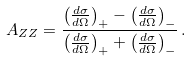Convert formula to latex. <formula><loc_0><loc_0><loc_500><loc_500>A _ { Z Z } = \frac { \left ( \frac { d \sigma } { d \Omega } \right ) _ { + } - \left ( \frac { d \sigma } { d \Omega } \right ) _ { - } } { \left ( \frac { d \sigma } { d \Omega } \right ) _ { + } + \left ( \frac { d \sigma } { d \Omega } \right ) _ { - } } \, .</formula> 